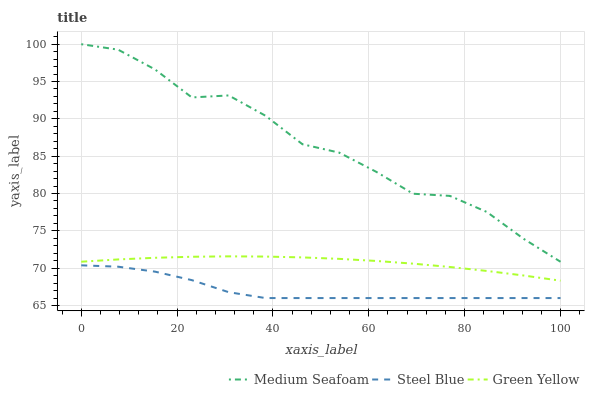Does Steel Blue have the minimum area under the curve?
Answer yes or no. Yes. Does Medium Seafoam have the maximum area under the curve?
Answer yes or no. Yes. Does Medium Seafoam have the minimum area under the curve?
Answer yes or no. No. Does Steel Blue have the maximum area under the curve?
Answer yes or no. No. Is Green Yellow the smoothest?
Answer yes or no. Yes. Is Medium Seafoam the roughest?
Answer yes or no. Yes. Is Steel Blue the smoothest?
Answer yes or no. No. Is Steel Blue the roughest?
Answer yes or no. No. Does Steel Blue have the lowest value?
Answer yes or no. Yes. Does Medium Seafoam have the lowest value?
Answer yes or no. No. Does Medium Seafoam have the highest value?
Answer yes or no. Yes. Does Steel Blue have the highest value?
Answer yes or no. No. Is Steel Blue less than Green Yellow?
Answer yes or no. Yes. Is Medium Seafoam greater than Steel Blue?
Answer yes or no. Yes. Does Steel Blue intersect Green Yellow?
Answer yes or no. No. 